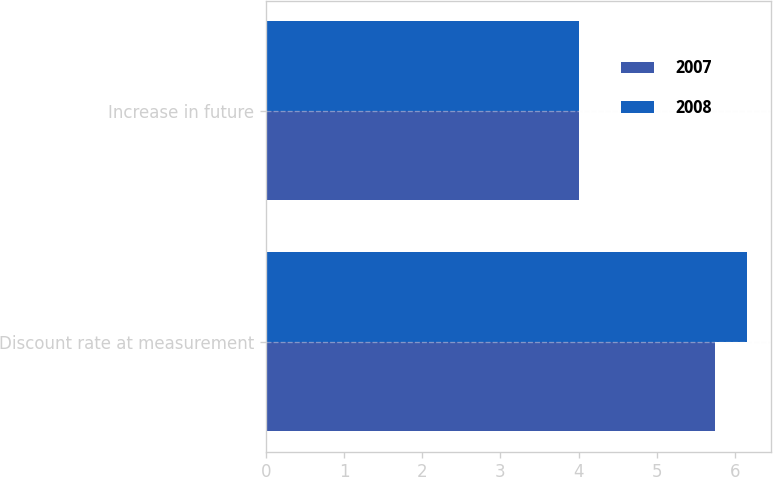Convert chart. <chart><loc_0><loc_0><loc_500><loc_500><stacked_bar_chart><ecel><fcel>Discount rate at measurement<fcel>Increase in future<nl><fcel>2007<fcel>5.75<fcel>4<nl><fcel>2008<fcel>6.15<fcel>4<nl></chart> 